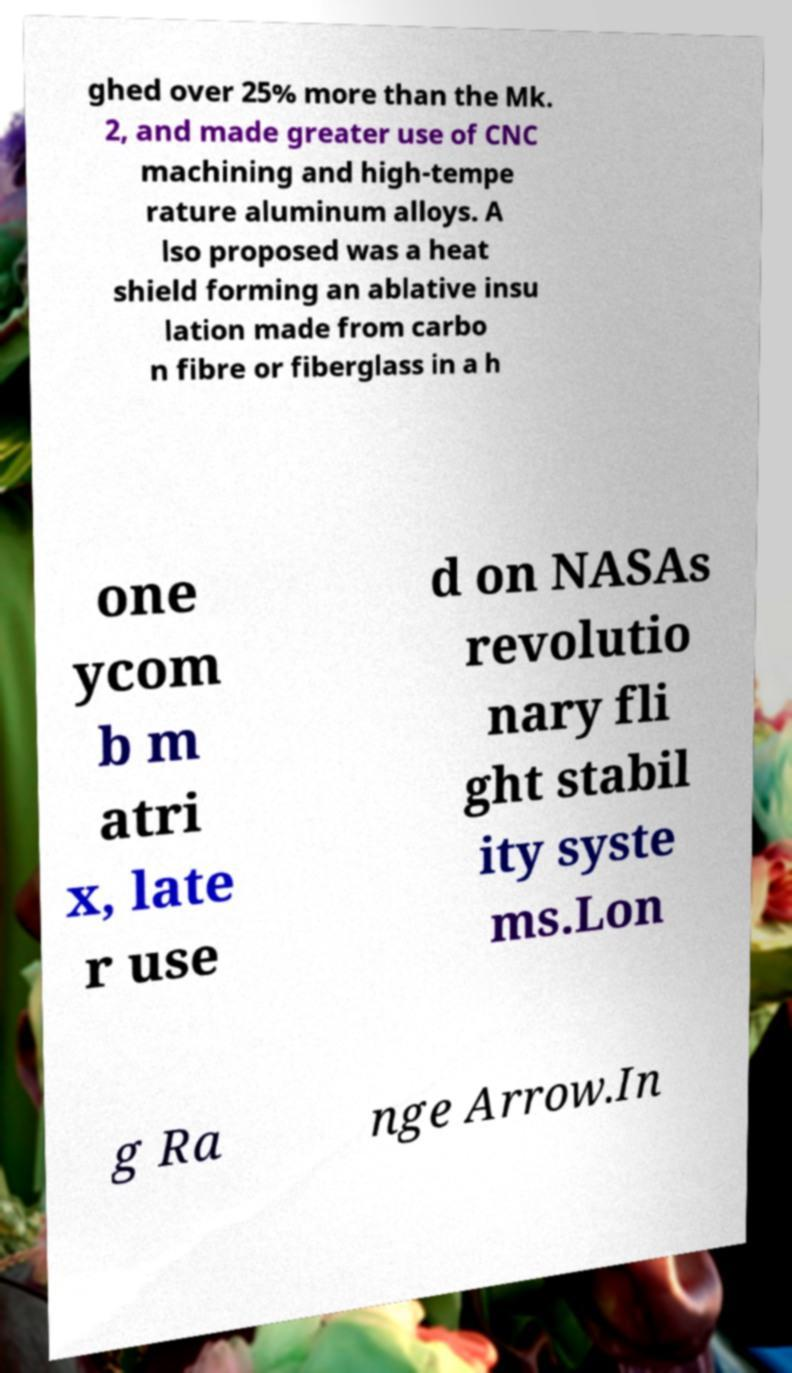What messages or text are displayed in this image? I need them in a readable, typed format. ghed over 25% more than the Mk. 2, and made greater use of CNC machining and high-tempe rature aluminum alloys. A lso proposed was a heat shield forming an ablative insu lation made from carbo n fibre or fiberglass in a h one ycom b m atri x, late r use d on NASAs revolutio nary fli ght stabil ity syste ms.Lon g Ra nge Arrow.In 